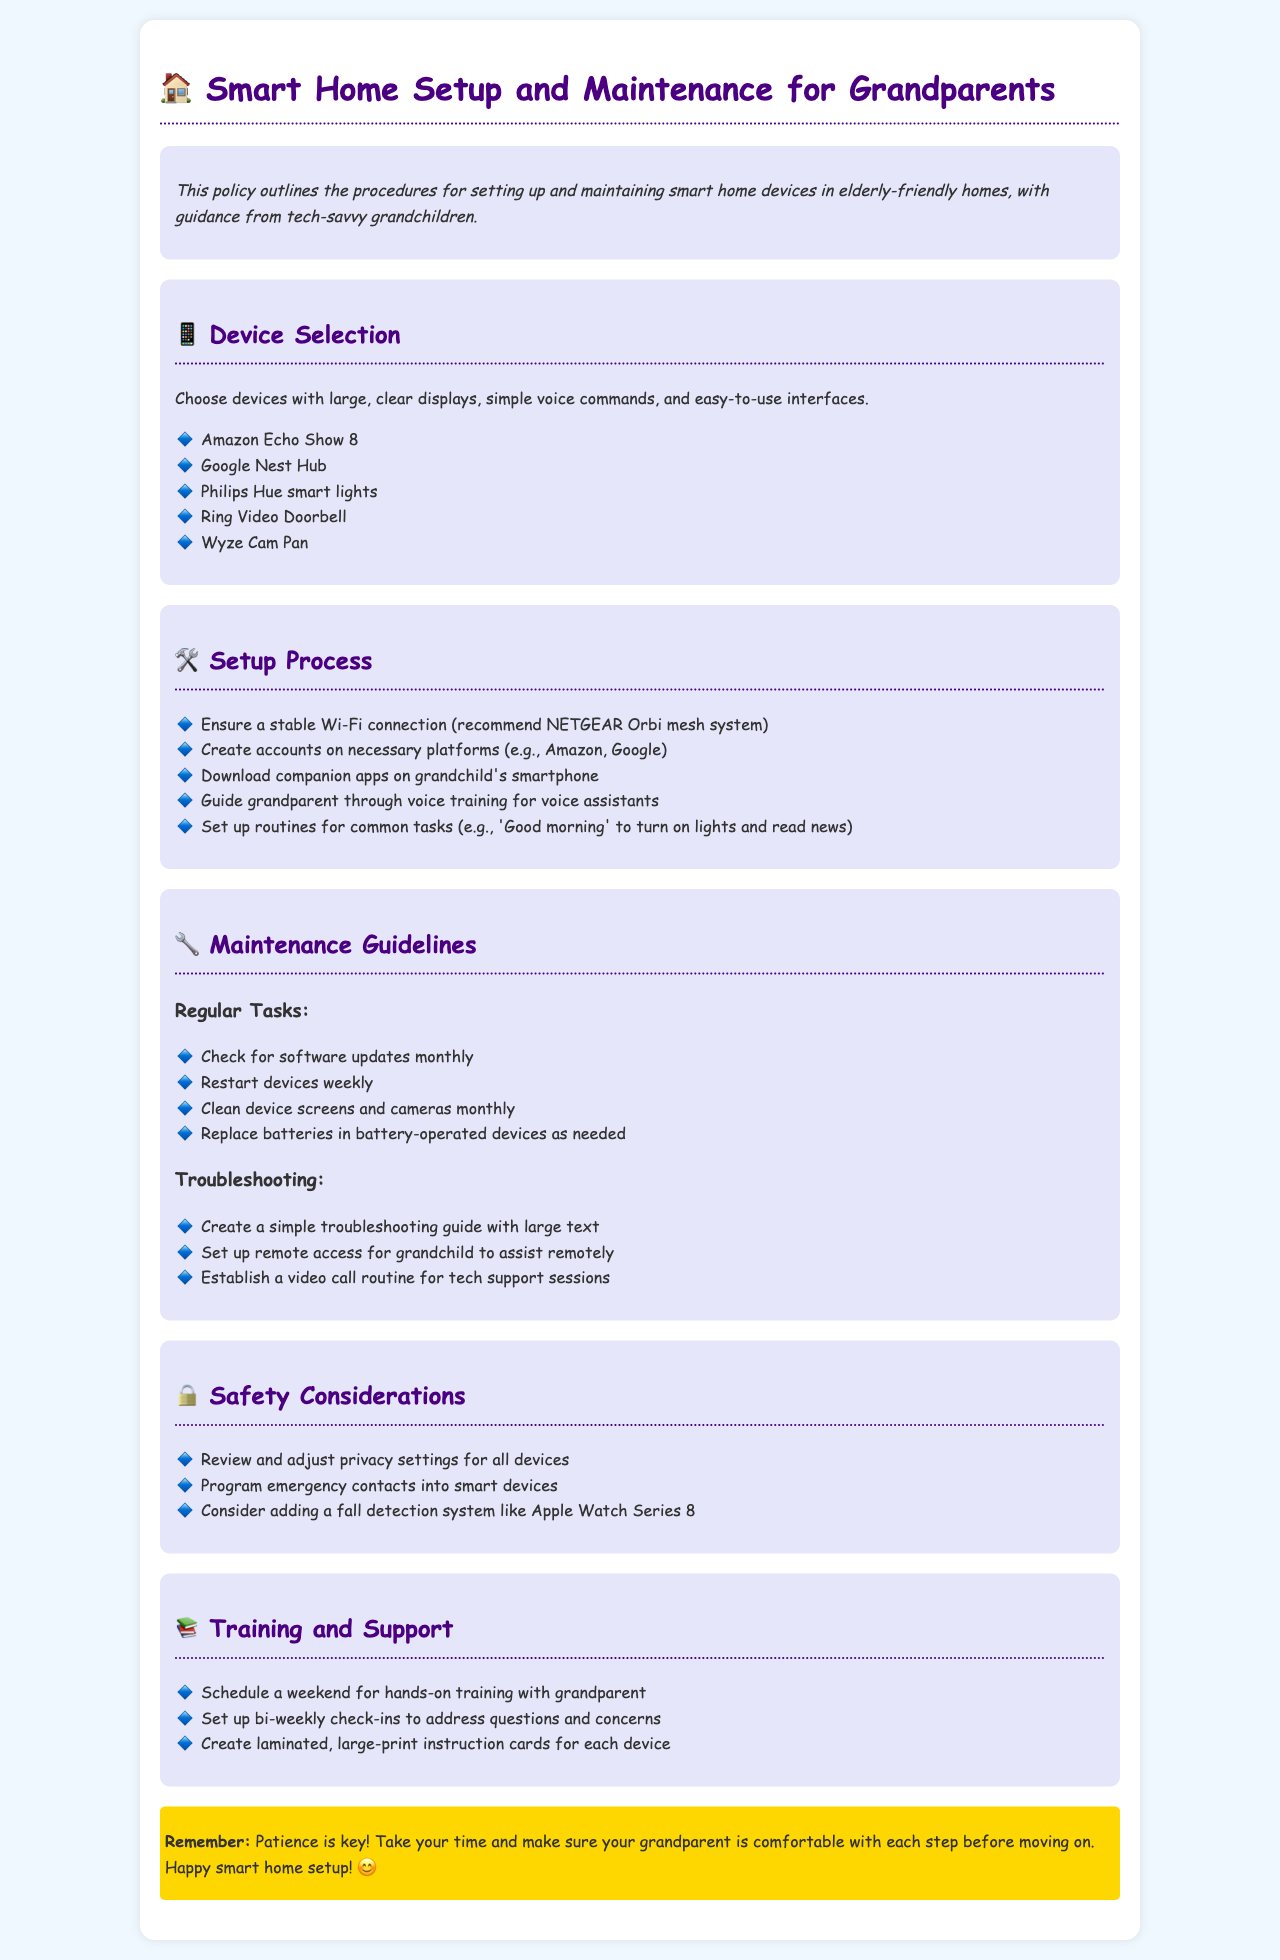What is the title of the document? The title is the heading displayed at the top of the document.
Answer: Smart Home Setup and Maintenance for Grandparents What device is recommended for video calling? The device listed for video calling among others in the device selection section.
Answer: Google Nest Hub What should you check for monthly? This refers to the regular maintenance task specified in the maintenance guidelines section.
Answer: Software updates How often should devices be restarted? The frequency of this regular maintenance task is mentioned in the maintenance guidelines.
Answer: Weekly What color is the highlighted section's background? This describes the visual appearance of the highlighted section in the document.
Answer: Yellow What should be created for troubleshooting? This refers to the resource that helps in addressing device issues, as suggested in the maintenance guidelines.
Answer: Troubleshooting guide What is one of the safety considerations mentioned? This question asks for an example of a safety aspect discussed in the document.
Answer: Emergency contacts What is a contingency plan for tech support? This refers to the established routine mentioned in the troubleshooting section.
Answer: Video call routine What is suggested for device training? This refers to the proposed action listed under training and support.
Answer: Hands-on training 